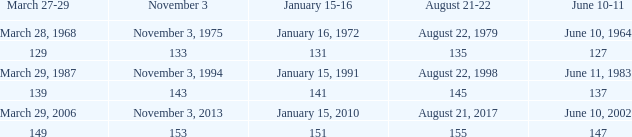What number is shown for january 15-16 when november 3 is 133? 131.0. 